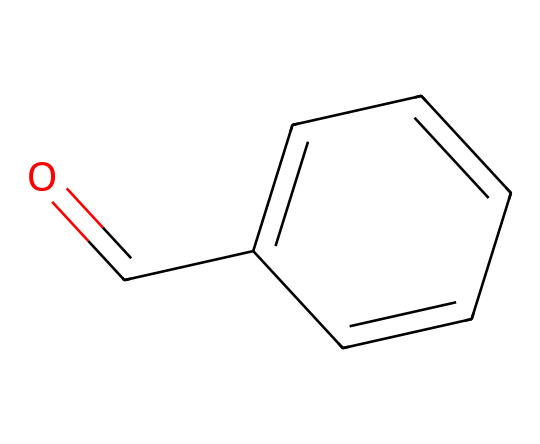How many carbon atoms are in benzaldehyde? The SMILES representation indicates the structure of benzaldehyde. Counting the number of 'C' symbols and lines connecting them, we find there are 7 carbon atoms in total.
Answer: 7 What functional group is present in benzaldehyde? Looking at the structure represented by the SMILES, the presence of the carbonyl group (C=O) confirms it contains an aldehyde functional group. Aldehydes are characterized by this functional group at the end of the carbon chain.
Answer: aldehyde What is the molecular formula of benzaldehyde? Analyzing the molecular structure, we identify there are 7 carbon (C), 6 hydrogen (H), and 1 oxygen (O) atom, leading to the molecular formula C7H6O.
Answer: C7H6O What type of aromatic compound is benzaldehyde? Benzaldehyde has a benzene ring (c1ccccc1) part of its structure. This aromatic ring is characteristic of aromatic compounds, specifically a mono-substituted aromatic aldehyde.
Answer: mono-substituted aromatic How many hydrogen atoms are directly bonded to the carbonyl carbon? The structure shows that the carbonyl carbon (which is part of the C=O group) is bonded only to one hydrogen atom. In aldehydes, the carbonyl carbon is always bonded to one hydrogen and the aromatic ring.
Answer: 1 Is benzaldehyde soluble in water? Aldehydes are generally polar due to the carbonyl group but the presence of the long hydrocarbon chain in benzaldehyde reduces its solubility in water. Therefore, it has low solubility in water.
Answer: low What is the characteristic smell associated with benzaldehyde? Benzaldehyde is known for its distinctive sweet, almond-like fragrance, which is often used in flavoring. This is directly related to its structure and the presence of the aldehyde group.
Answer: almond-like 